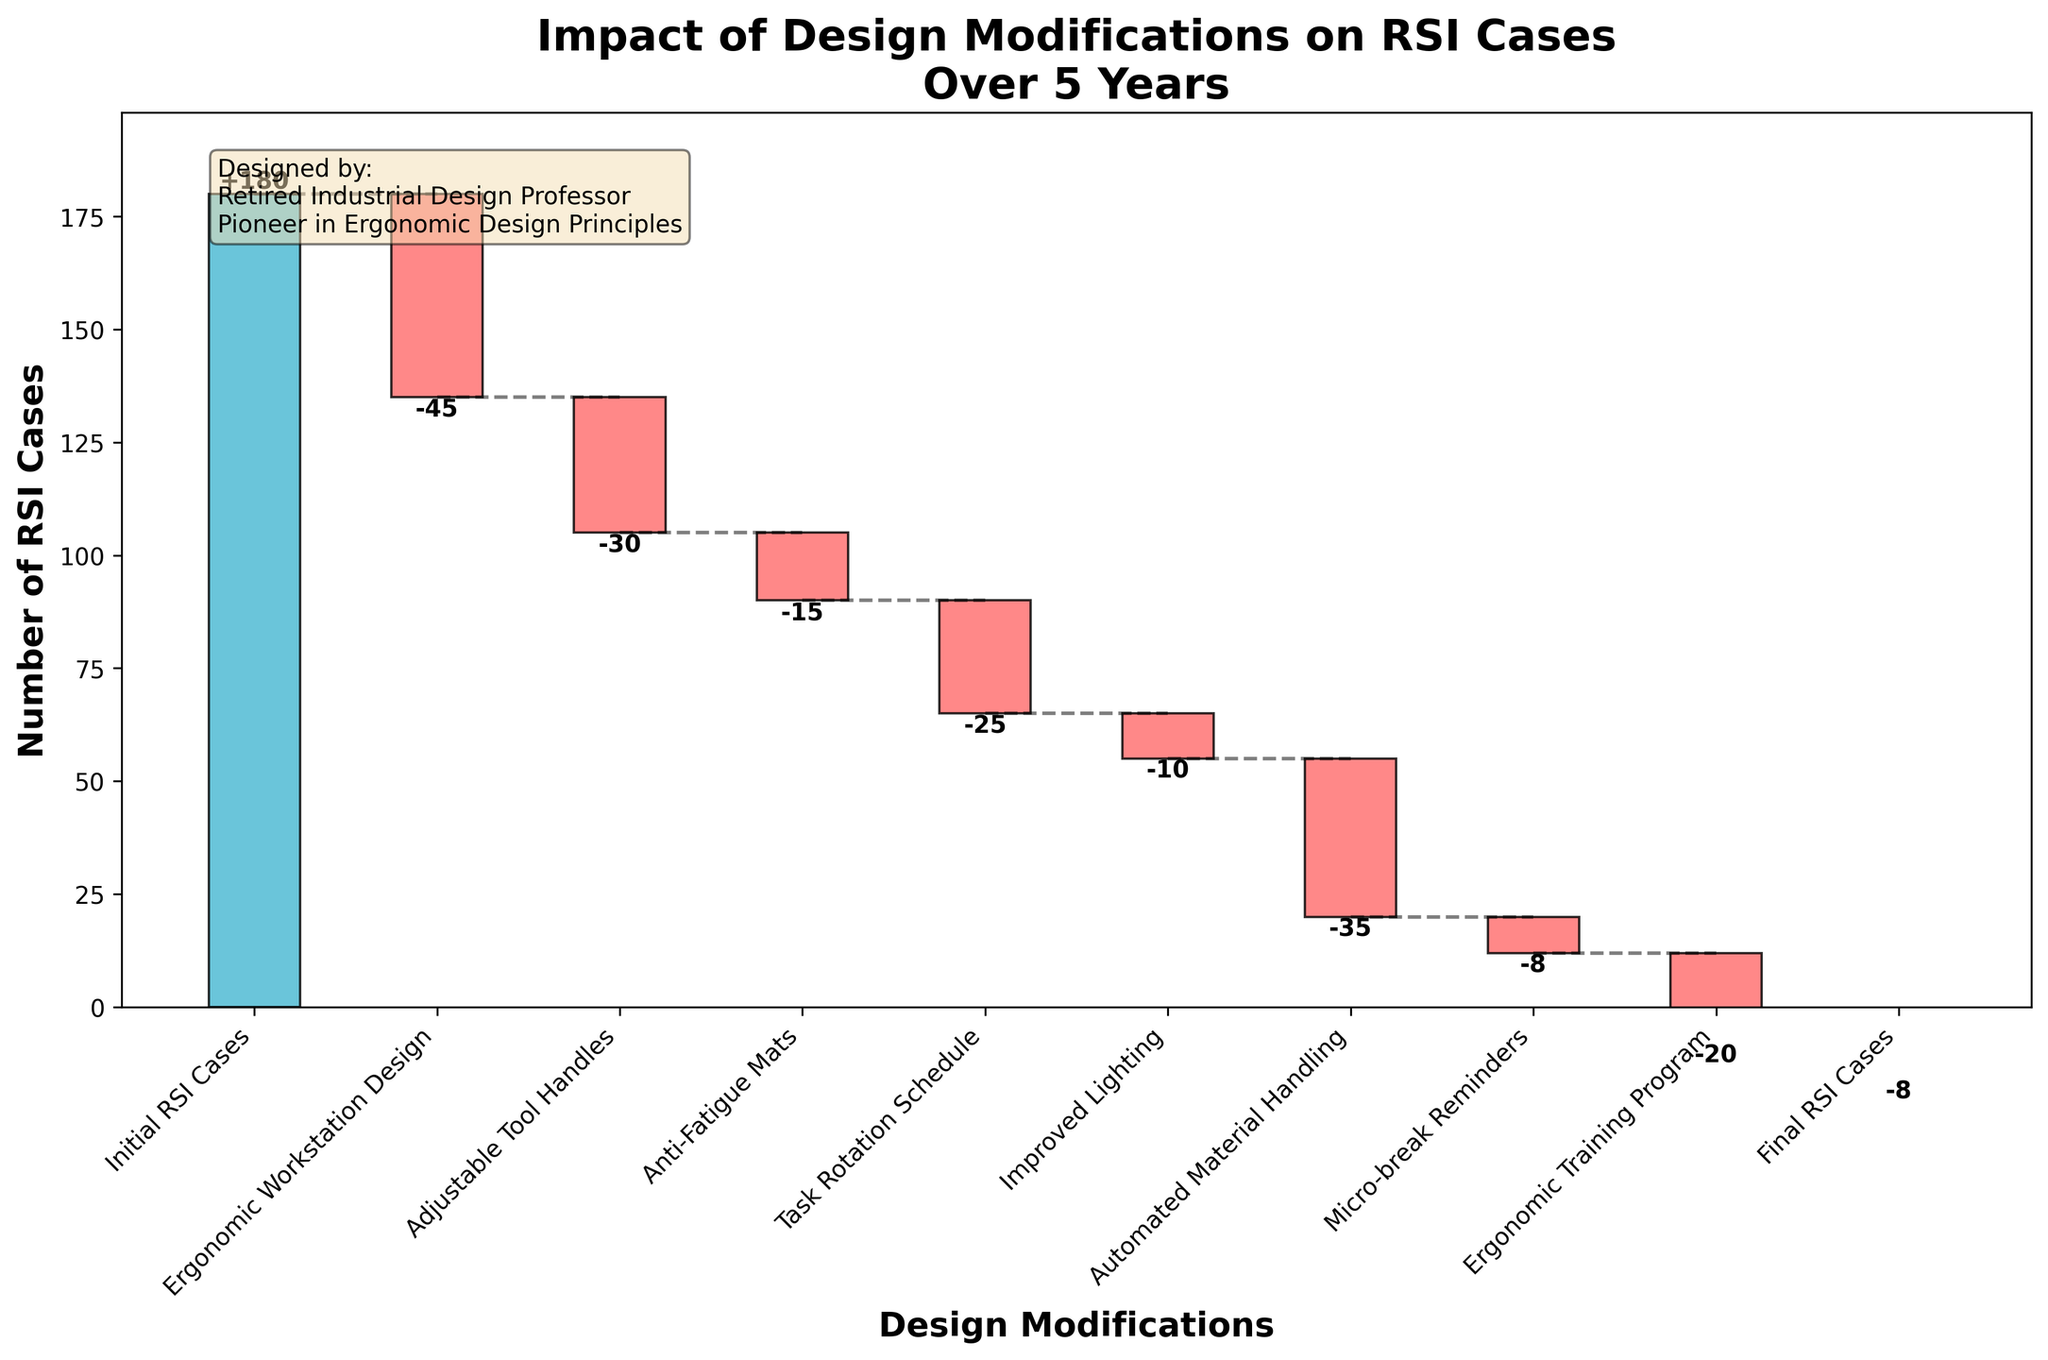What is the title of the chart? The title of the chart can be found at the top. It summarizes the main topic of the chart.
Answer: Impact of Design Modifications on RSI Cases Over 5 Years How many design modifications are shown in the chart? Count the bars, excluding the initial and final data points, to find the number of modifications.
Answer: Seven What category shows the highest reduction in RSI cases? Look for the category with the largest negative value in terms of the reduction of RSI cases.
Answer: Ergonomic Workstation Design What is the final number of RSI cases after all modifications? Look at the final bar labeled "Final RSI Cases" to find the number of remaining cases.
Answer: 8 Which modification had the smallest impact on reducing RSI cases? Identify the category with the smallest negative value among the modifications.
Answer: Micro-break Reminders By how much did the ergonomic workstation design reduce RSI cases? Refer to the bar labeled "Ergonomic Workstation Design" and check the numeric value associated with it.
Answer: 45 How much total reduction in RSI cases was achieved by all design modifications combined? Sum all the negative values of the design modifications to find the total reduction.
Answer: 183 What is the difference between the reduction impact of Adjustable Tool Handles and Anti-Fatigue Mats? Subtract the value of Anti-Fatigue Mats from the value of Adjustable Tool Handles.
Answer: 15 How does the impact of Automated Material Handling compare to the Task Rotation Schedule? Compare the numeric values of the bars for Automated Material Handling and Task Rotation Schedule.
Answer: Automated Material Handling has a greater reduction What is the cumulative effect of Ergonomic Training Program and Improved Lighting on RSI cases? Add the negative values of Ergonomic Training Program and Improved Lighting to find their combined impact.
Answer: 30 